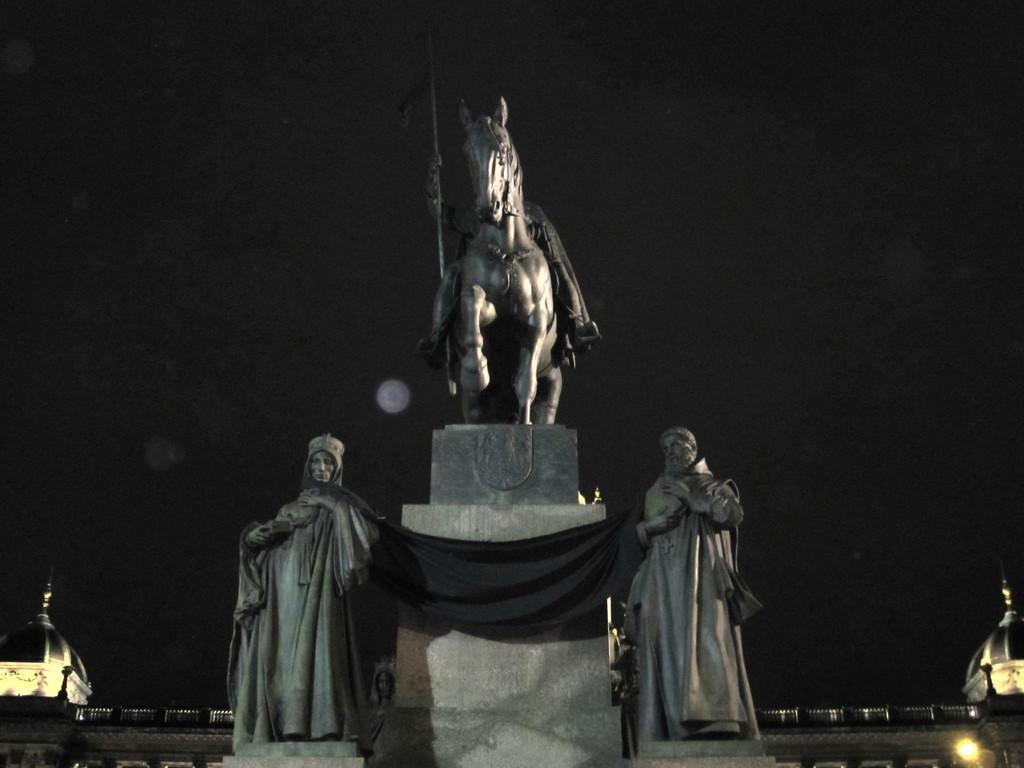In one or two sentences, can you explain what this image depicts? Here we can see sculptures and a light. There is a dark background. 